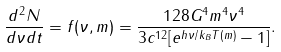<formula> <loc_0><loc_0><loc_500><loc_500>\frac { d ^ { 2 } N } { d \nu d t } = f ( \nu , m ) = \frac { 1 2 8 G ^ { 4 } m ^ { 4 } \nu ^ { 4 } } { 3 c ^ { 1 2 } [ e ^ { h \nu / k _ { B } T ( m ) } - 1 ] } .</formula> 